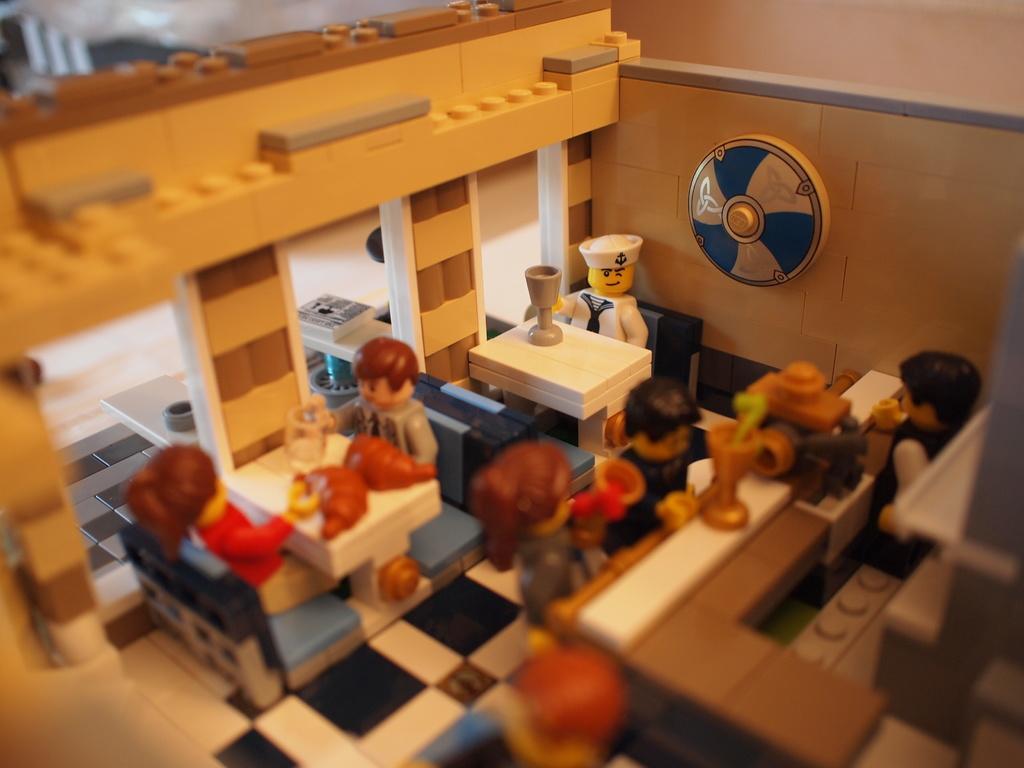Describe this image in one or two sentences. This is a toy house. 